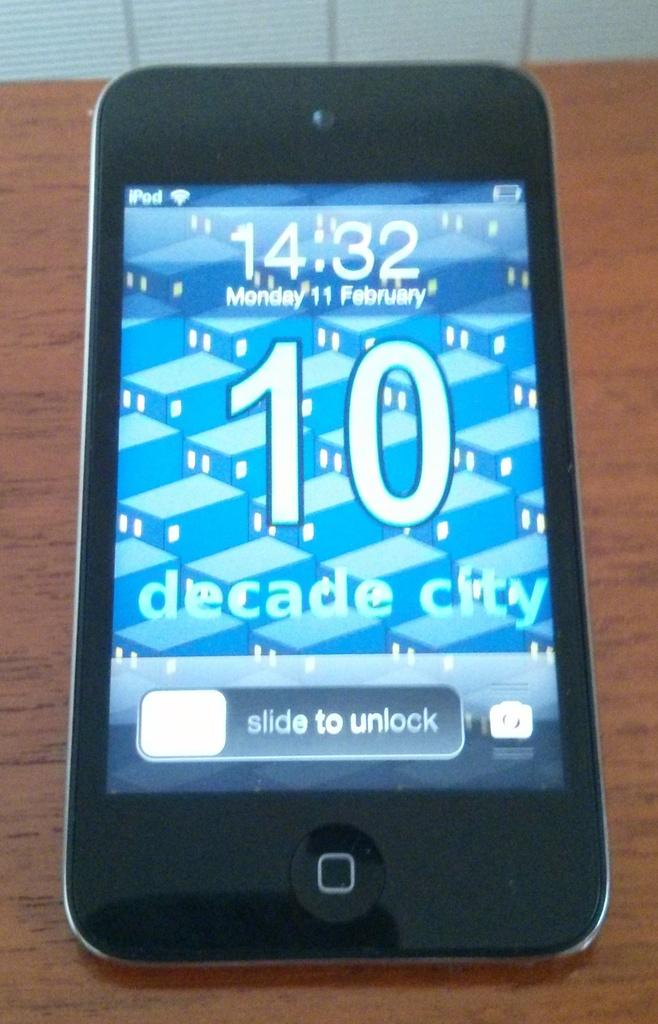What is the main object in the image? There is a mobile in the image. What is the mobile placed on? The mobile is on a wooden surface. What can be seen on the mobile's screen? The mobile's screen displays numbers, text, and symbols. Can you describe the object at the top of the image? There is a white color object at the top of the image. What type of car is parked next to the mobile in the image? There is no car present in the image; it only features a mobile on a wooden surface. 